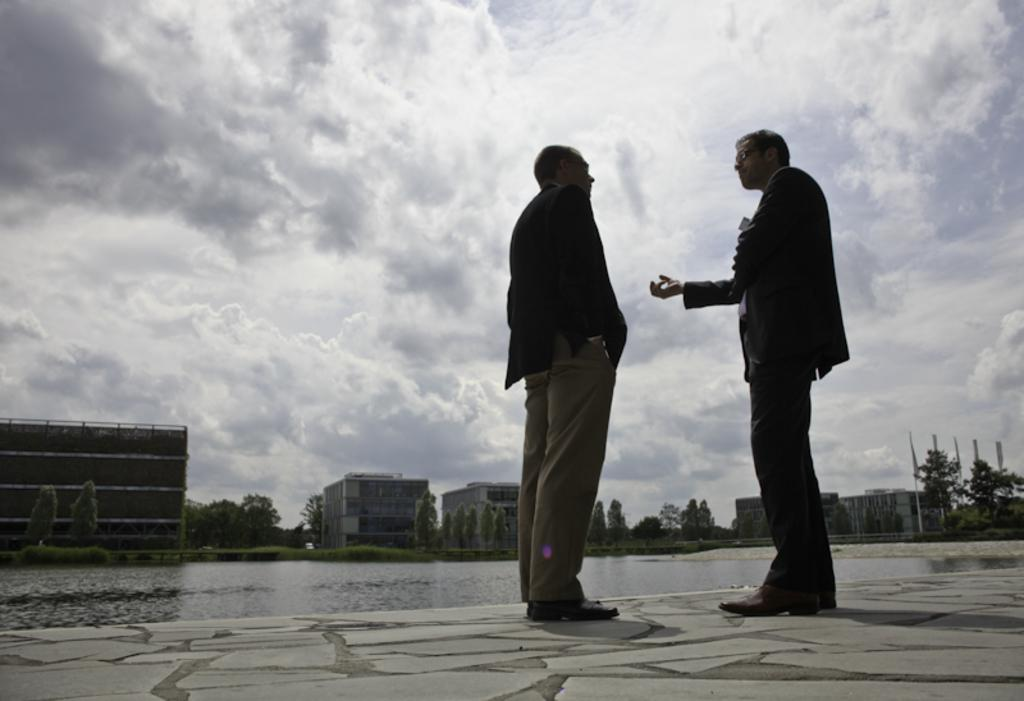How many people are standing in the image? There are two persons standing in the image. What can be seen in the background of the image? Water, trees, buildings, and the sky with clouds are visible in the background. Can you describe the sky in the image? The sky in the image is visible in the background with clouds. What type of rail is being used for learning in the image? There is no rail or learning activity present in the image. 